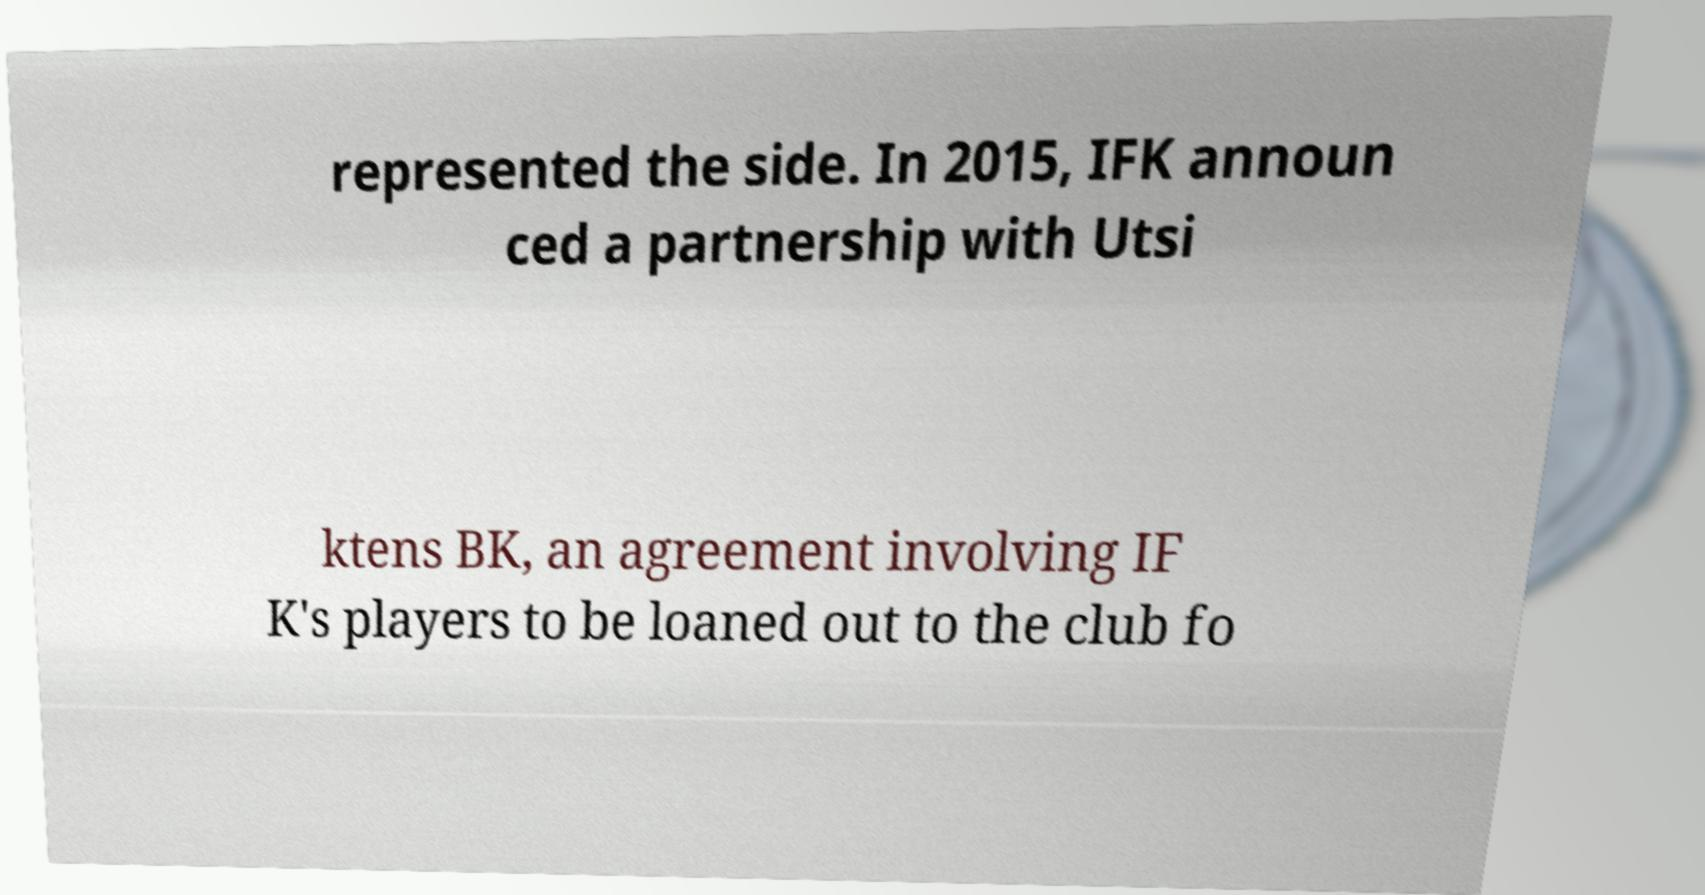Please read and relay the text visible in this image. What does it say? represented the side. In 2015, IFK announ ced a partnership with Utsi ktens BK, an agreement involving IF K's players to be loaned out to the club fo 